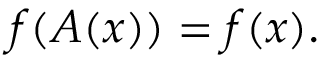<formula> <loc_0><loc_0><loc_500><loc_500>f ( A ( x ) ) = f ( x ) .</formula> 